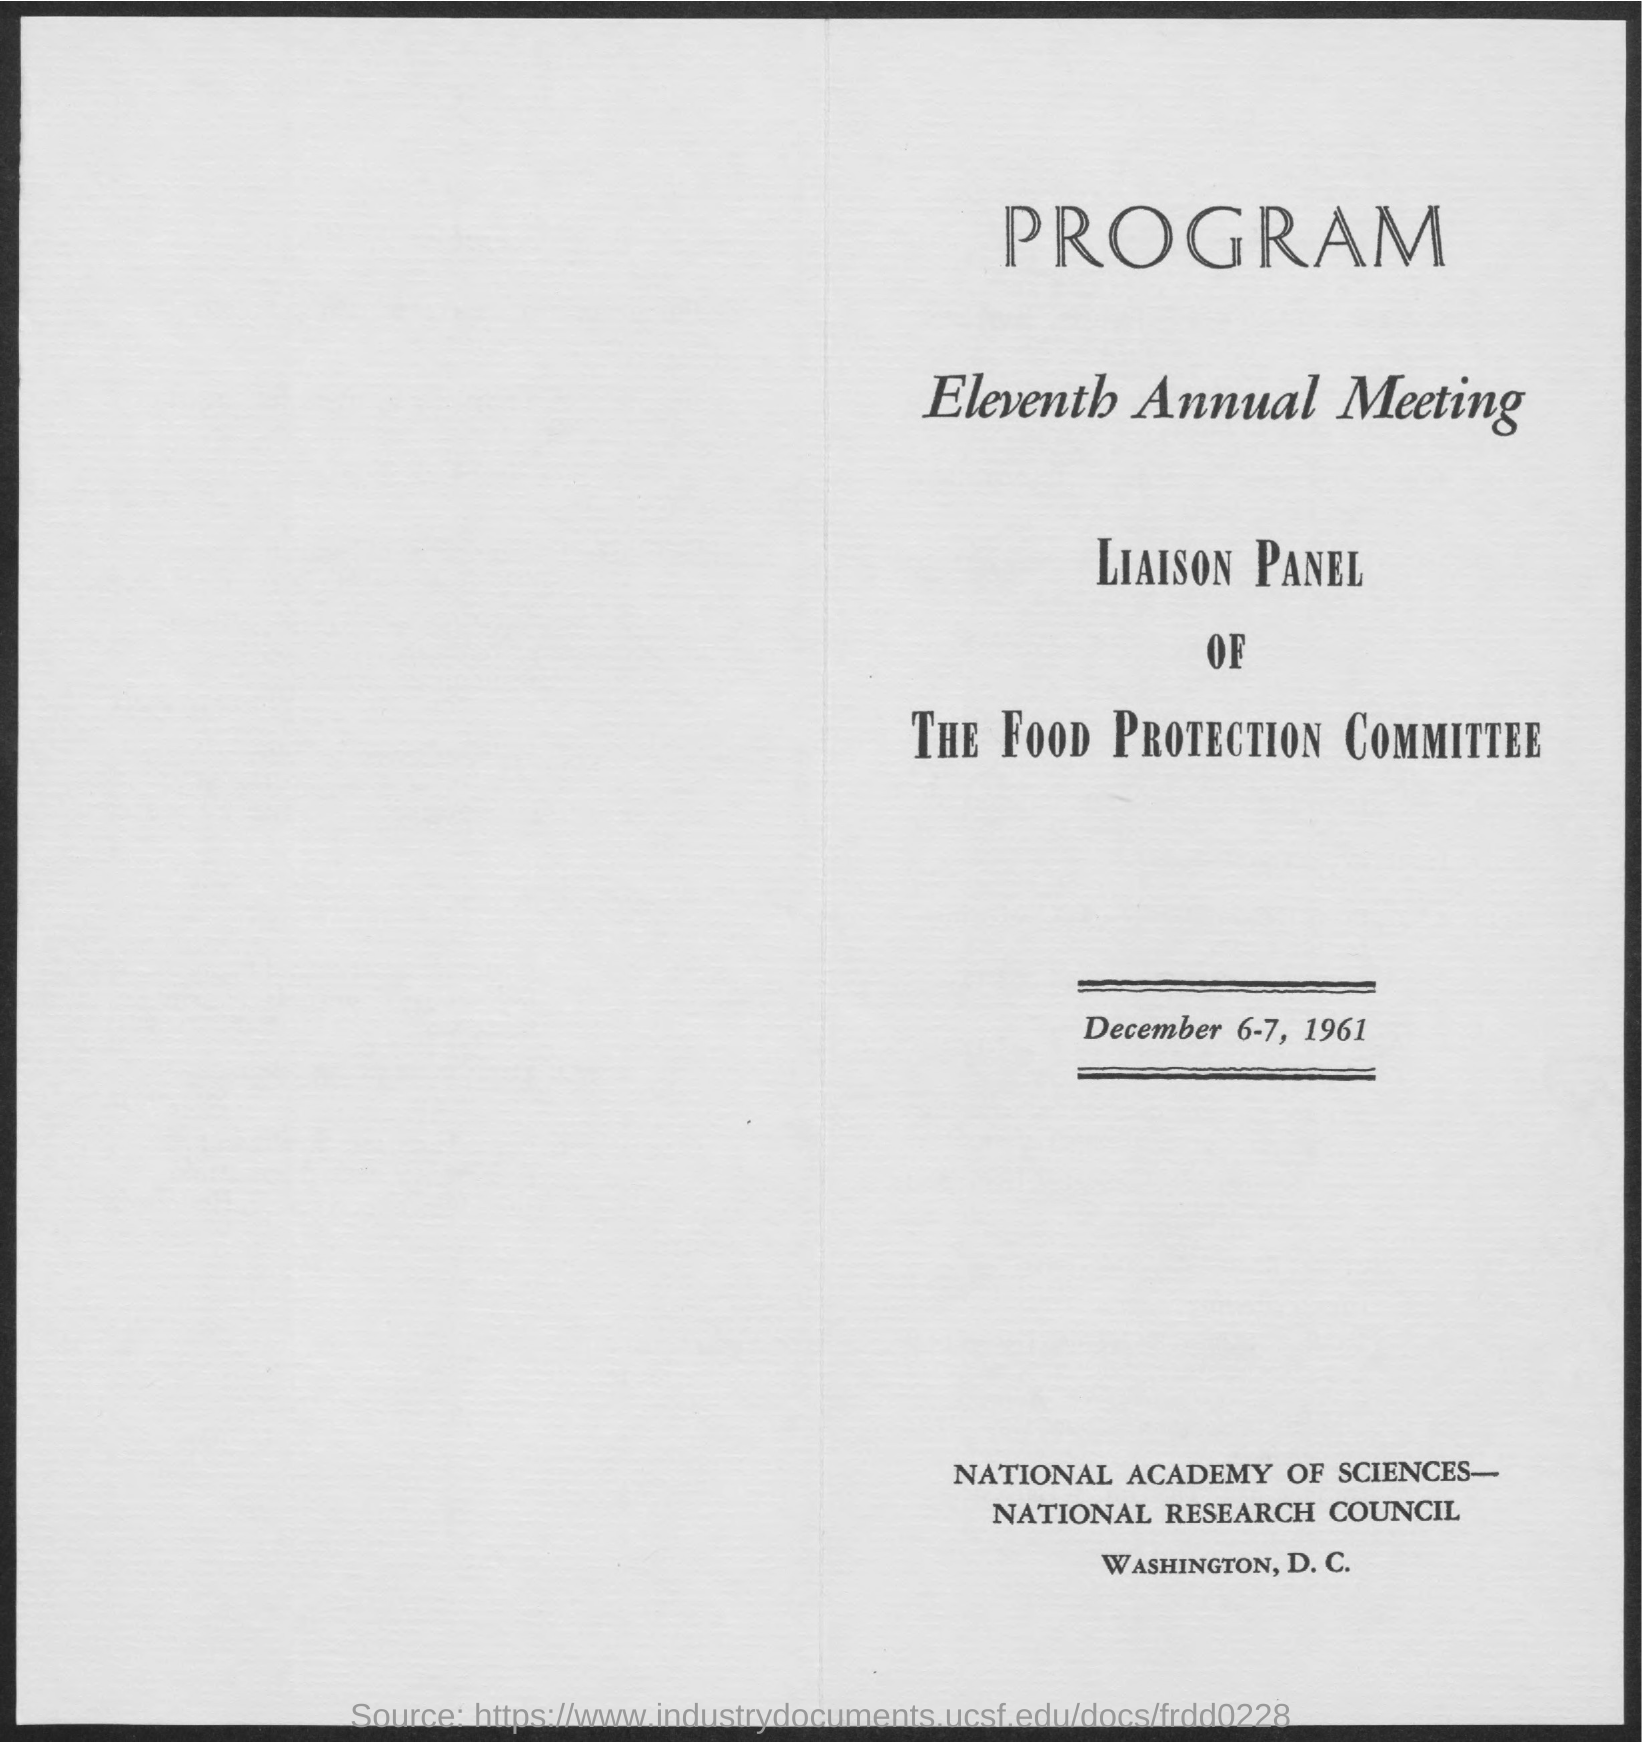Point out several critical features in this image. The eleventh Annual Meeting will take place on December 6-7, 1961. 